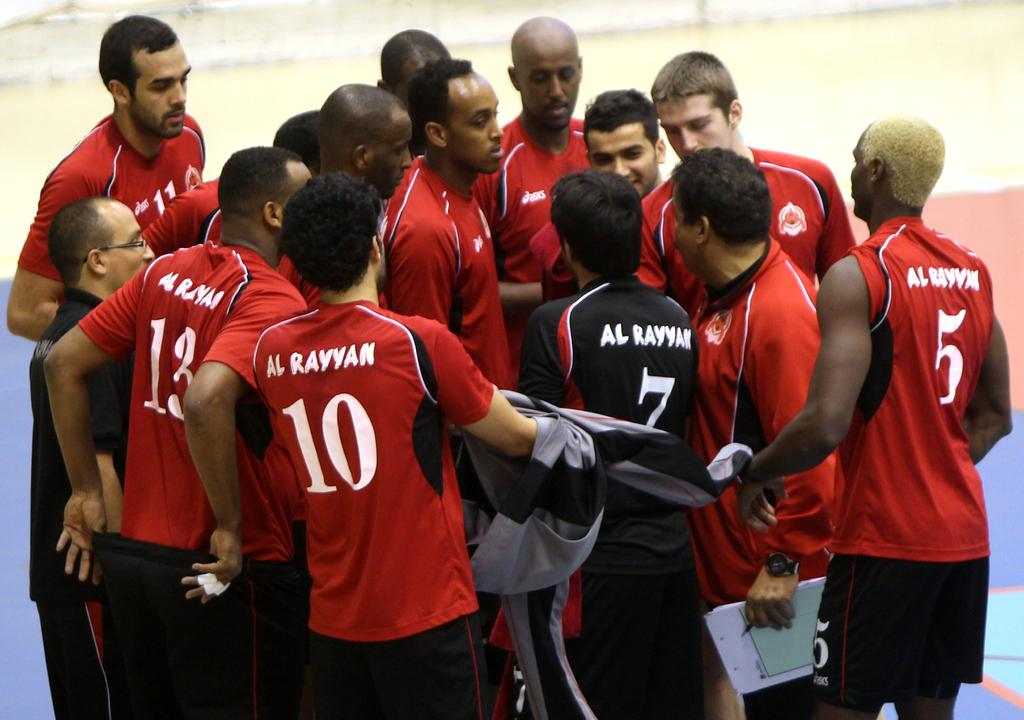<image>
Describe the image concisely. group of players with al rayyan uniforms huddled together 